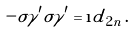<formula> <loc_0><loc_0><loc_500><loc_500>- \sigma { \gamma } ^ { \prime } \sigma { \gamma } ^ { \prime } = { \i d } _ { 2 n } \, .</formula> 